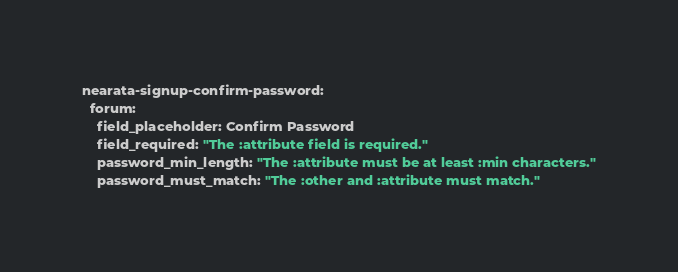<code> <loc_0><loc_0><loc_500><loc_500><_YAML_>nearata-signup-confirm-password:
  forum:
    field_placeholder: Confirm Password
    field_required: "The :attribute field is required."
    password_min_length: "The :attribute must be at least :min characters."
    password_must_match: "The :other and :attribute must match."
</code> 